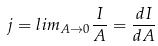<formula> <loc_0><loc_0><loc_500><loc_500>j = l i m _ { A \rightarrow 0 } \frac { I } { A } = \frac { d I } { d A }</formula> 